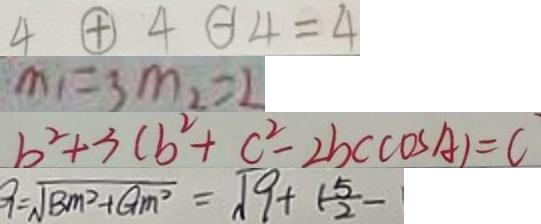<formula> <loc_0><loc_0><loc_500><loc_500>4 \textcircled { + } 4 H 4 = 4 
 m _ { 1 } = 3 m _ { 2 } = 2 
 b ^ { 2 } + 3 ( b ^ { 2 } + c ^ { 2 } - 2 b c \cos A ) = C 
 G = \sqrt { B m ^ { 2 } + G m ^ { 2 } } = \sqrt { 9 + ( \frac { 5 } { 2 } - }</formula> 